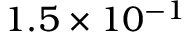<formula> <loc_0><loc_0><loc_500><loc_500>1 . 5 \times 1 0 ^ { - 1 }</formula> 